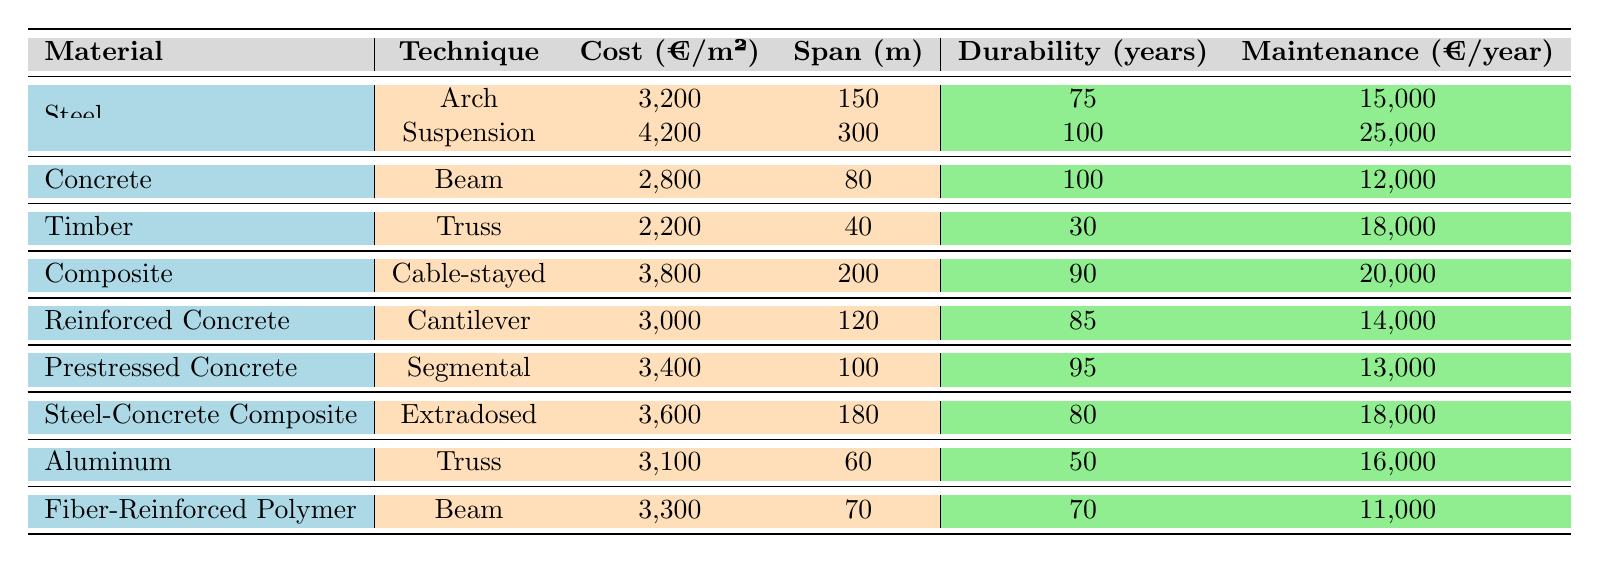What is the cost per square meter of the suspension technique using steel? The table lists the cost per square meter for steel used in the suspension technique as 4,200.
Answer: 4,200 Which technique has the lowest maintenance cost per year? By comparing the maintenance costs per year for all techniques, the timber truss has the lowest maintenance cost at 18,000.
Answer: 18,000 What is the average cost per square meter of composite materials? The table contains one composite material with a cost of 3,800. As there is only one data point, the average cost is simply this value.
Answer: 3,800 Is the durability of prestressed concrete higher than that of timber? The prestressed concrete has a durability of 95 years, while the timber has a durability of 30 years. Since 95 is greater than 30, this statement is true.
Answer: Yes What is the total span length of all steel constructions listed? The span lengths for the steel techniques are: 150 (arch) + 300 (suspension) = 450. Adding these gives a total span length of 450.
Answer: 450 Which material has the highest cost per square meter and what is that cost? Looking through the table, the composite material using the cable-stayed technique has the highest cost at 3,800 per square meter.
Answer: 3,800 Are there more techniques for steel or for concrete materials? The table shows two techniques for steel (arch and suspension) and one for concrete (beam). Since 2 is greater than 1, there are more techniques for steel.
Answer: Yes What is the difference in maintenance costs between the arch and the cable-stayed techniques? The arch technique has a maintenance cost of 15,000 per year, while the cable-stayed has 20,000. The difference is 20,000 - 15,000 = 5,000.
Answer: 5,000 